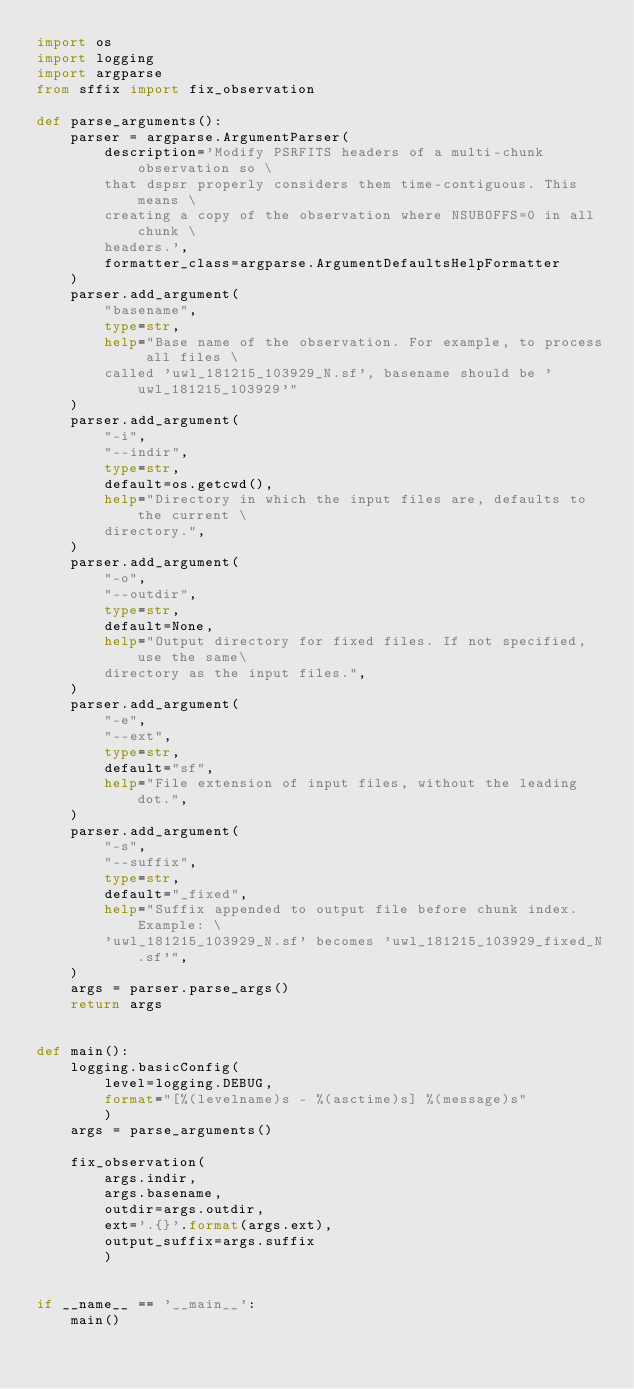Convert code to text. <code><loc_0><loc_0><loc_500><loc_500><_Python_>import os
import logging
import argparse
from sffix import fix_observation

def parse_arguments():
    parser = argparse.ArgumentParser(
        description='Modify PSRFITS headers of a multi-chunk observation so \
        that dspsr properly considers them time-contiguous. This means \
        creating a copy of the observation where NSUBOFFS=0 in all chunk \
        headers.',
        formatter_class=argparse.ArgumentDefaultsHelpFormatter
    )
    parser.add_argument(
        "basename",
        type=str,
        help="Base name of the observation. For example, to process all files \
        called 'uwl_181215_103929_N.sf', basename should be 'uwl_181215_103929'"
    )
    parser.add_argument(
        "-i",
        "--indir",
        type=str,
        default=os.getcwd(),
        help="Directory in which the input files are, defaults to the current \
        directory.",
    )
    parser.add_argument(
        "-o",
        "--outdir",
        type=str,
        default=None,
        help="Output directory for fixed files. If not specified, use the same\
        directory as the input files.",
    )
    parser.add_argument(
        "-e",
        "--ext",
        type=str,
        default="sf",
        help="File extension of input files, without the leading dot.",
    )
    parser.add_argument(
        "-s",
        "--suffix",
        type=str,
        default="_fixed",
        help="Suffix appended to output file before chunk index. Example: \
        'uwl_181215_103929_N.sf' becomes 'uwl_181215_103929_fixed_N.sf'",
    )
    args = parser.parse_args()
    return args


def main():
    logging.basicConfig(
        level=logging.DEBUG, 
        format="[%(levelname)s - %(asctime)s] %(message)s"
        )
    args = parse_arguments()

    fix_observation(
        args.indir,
        args.basename, 
        outdir=args.outdir, 
        ext='.{}'.format(args.ext),
        output_suffix=args.suffix
        )


if __name__ == '__main__':
    main()</code> 